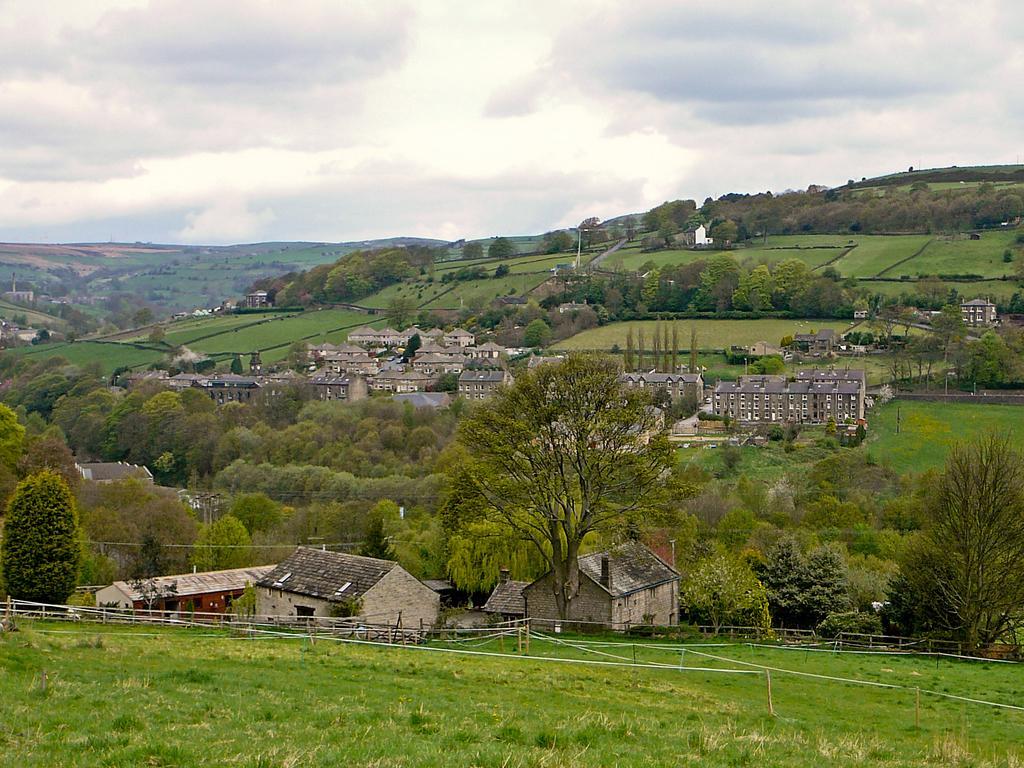In one or two sentences, can you explain what this image depicts? In this image there are hills. There are buildings, trees and grass on the hills. At the bottom there is a fencing on the hills. At the top there is the sky. 